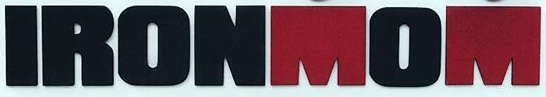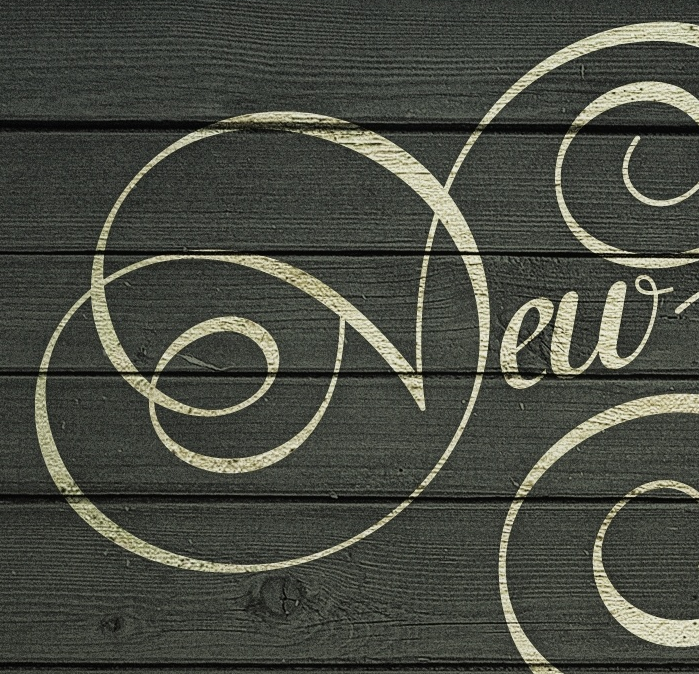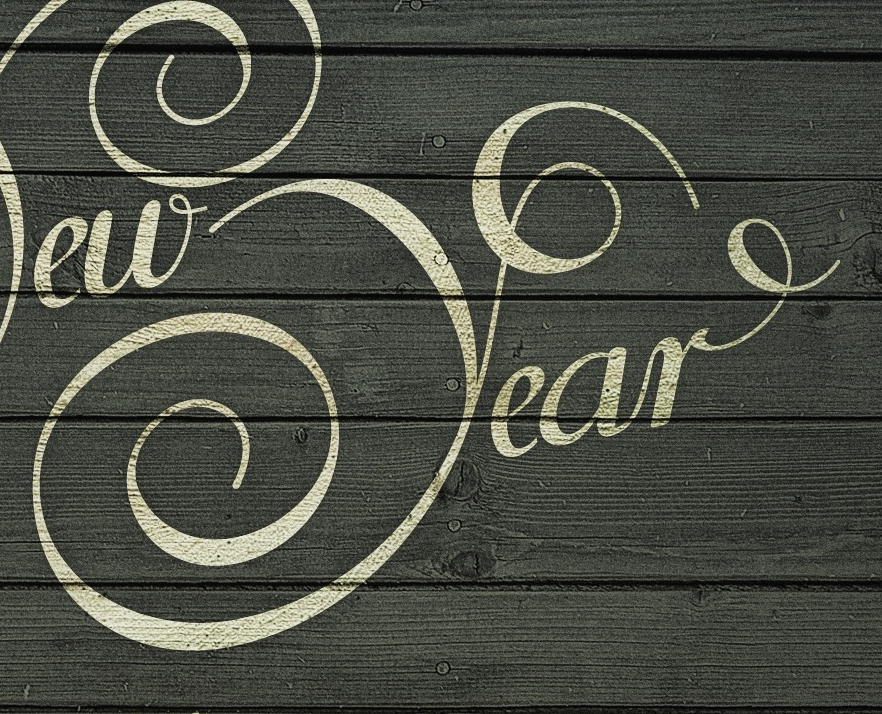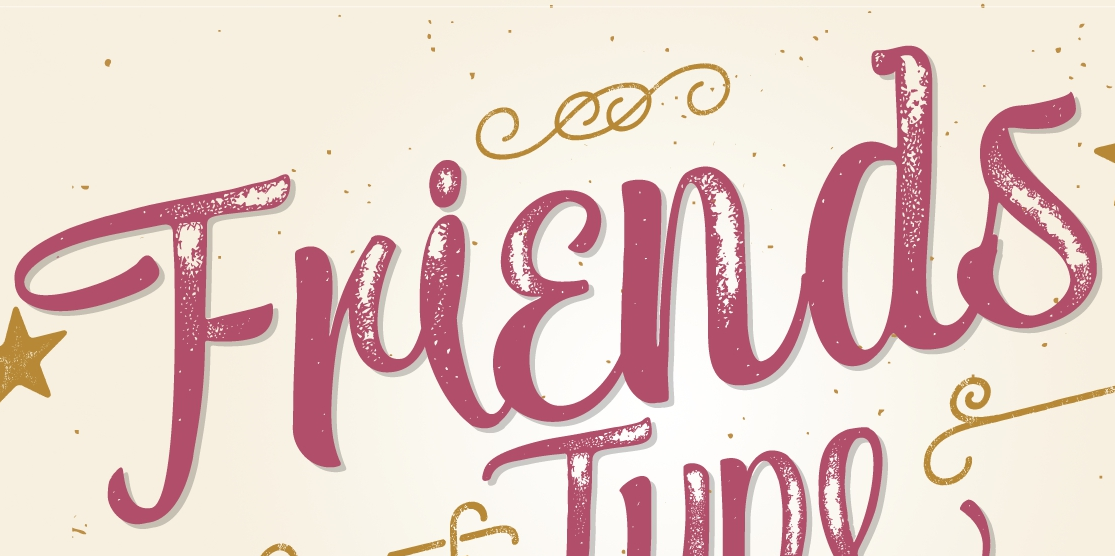Transcribe the words shown in these images in order, separated by a semicolon. IRONMOM; New; Year; Friends 